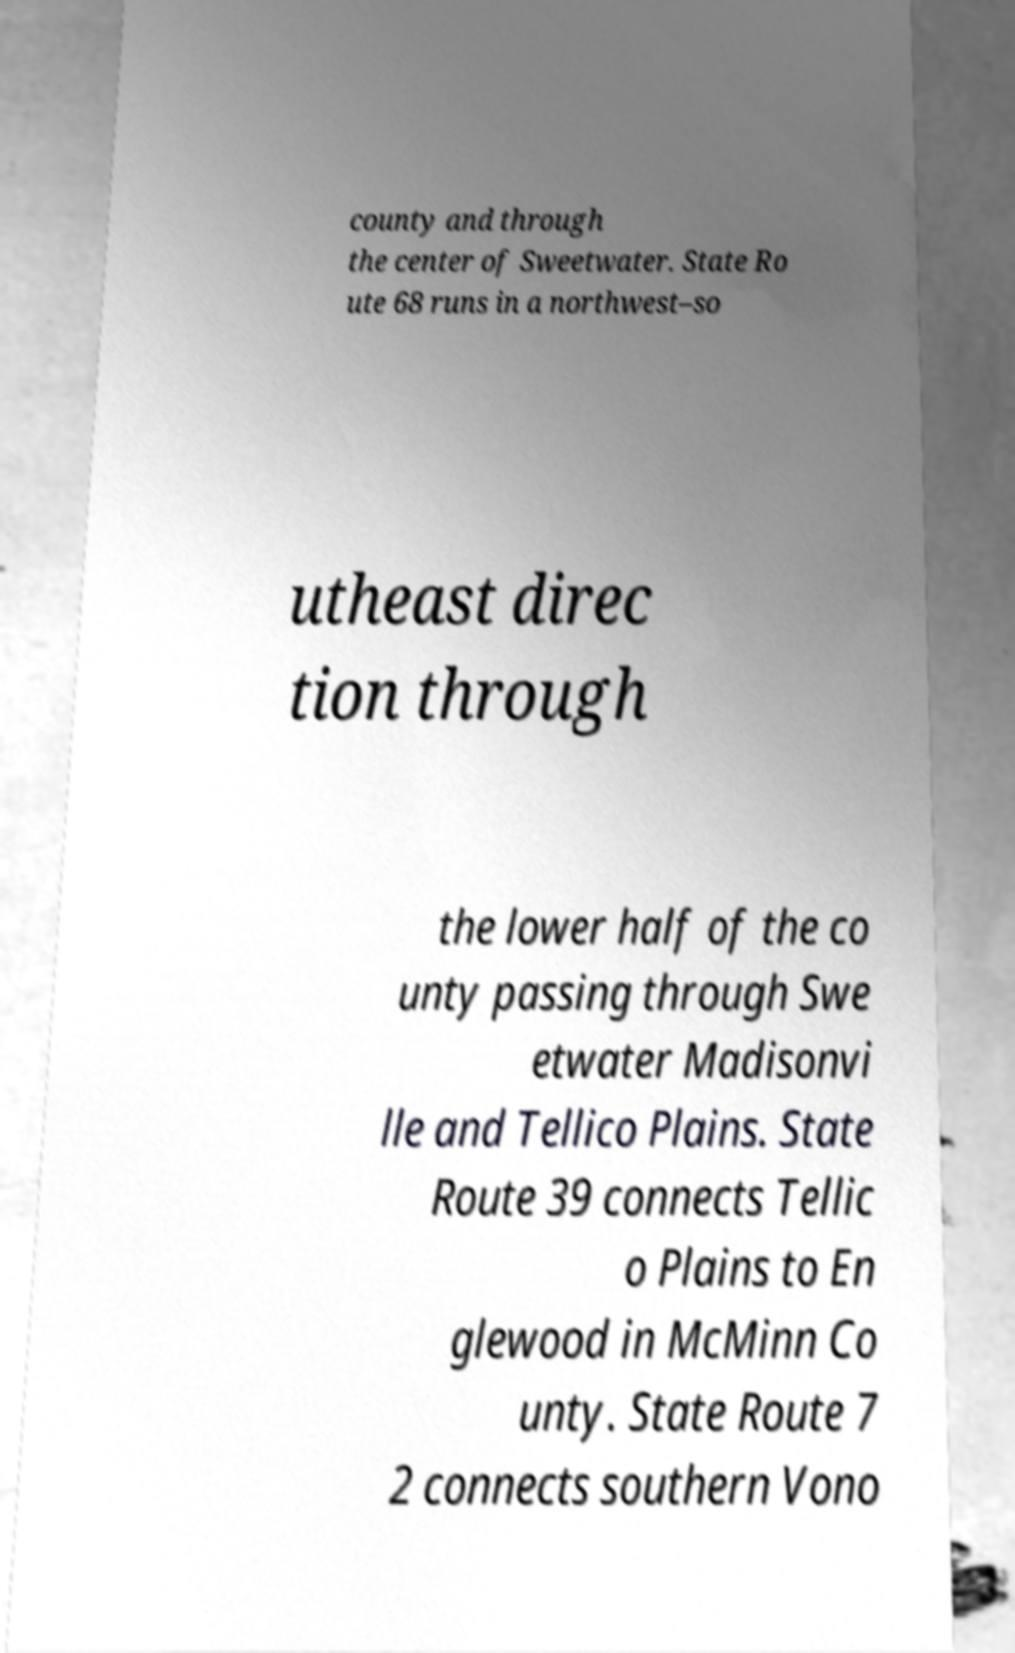Can you read and provide the text displayed in the image?This photo seems to have some interesting text. Can you extract and type it out for me? county and through the center of Sweetwater. State Ro ute 68 runs in a northwest–so utheast direc tion through the lower half of the co unty passing through Swe etwater Madisonvi lle and Tellico Plains. State Route 39 connects Tellic o Plains to En glewood in McMinn Co unty. State Route 7 2 connects southern Vono 